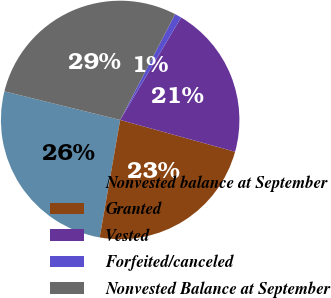Convert chart to OTSL. <chart><loc_0><loc_0><loc_500><loc_500><pie_chart><fcel>Nonvested balance at September<fcel>Granted<fcel>Vested<fcel>Forfeited/canceled<fcel>Nonvested Balance at September<nl><fcel>26.11%<fcel>23.45%<fcel>20.76%<fcel>0.91%<fcel>28.77%<nl></chart> 